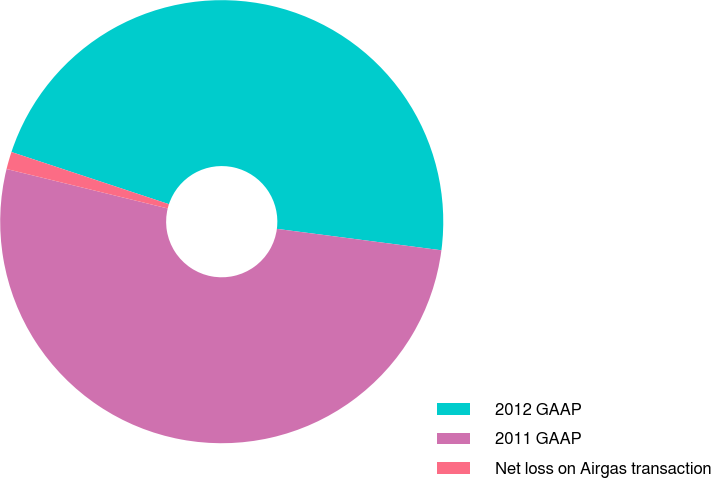Convert chart to OTSL. <chart><loc_0><loc_0><loc_500><loc_500><pie_chart><fcel>2012 GAAP<fcel>2011 GAAP<fcel>Net loss on Airgas transaction<nl><fcel>46.97%<fcel>51.76%<fcel>1.27%<nl></chart> 